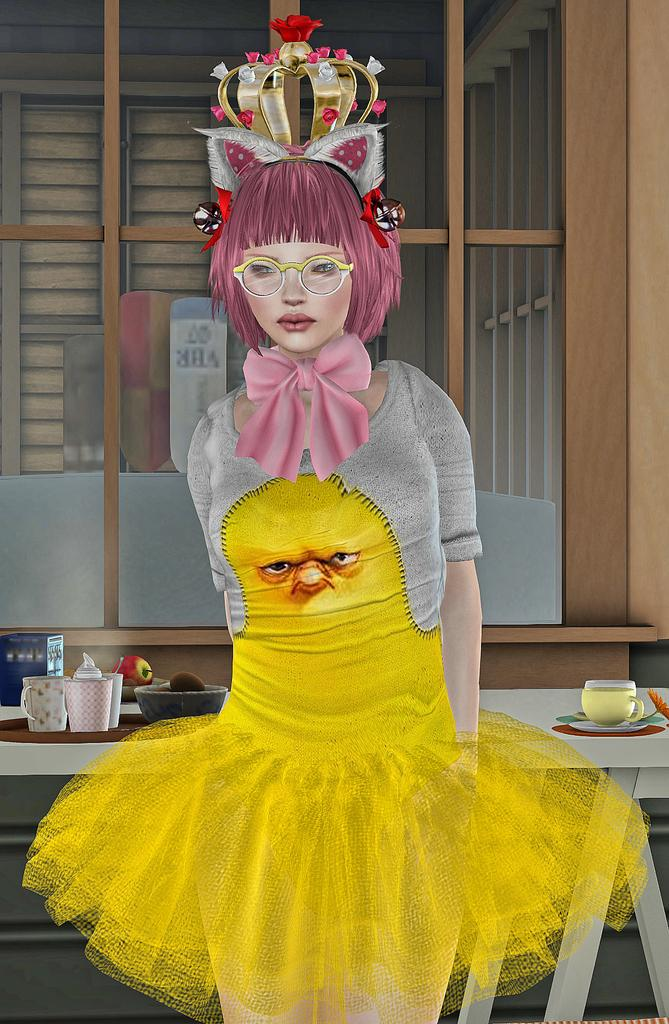What type of image is in the picture? There is an animated image of a girl in the picture. What can be seen in the background of the image? There is a table, cups, and food items in the background of the image. What type of paper is the girl holding in the image? There is no paper visible in the image; the girl is animated and not holding any objects. 